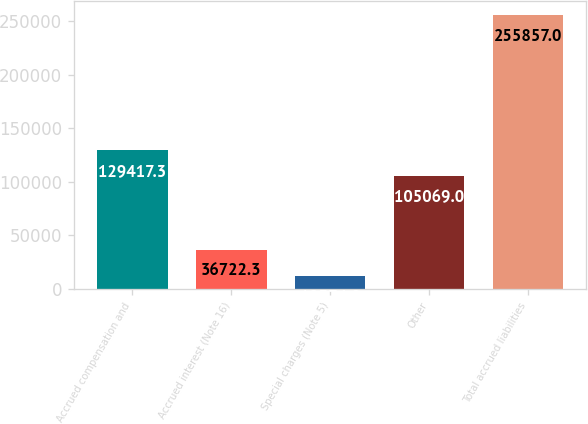Convert chart to OTSL. <chart><loc_0><loc_0><loc_500><loc_500><bar_chart><fcel>Accrued compensation and<fcel>Accrued interest (Note 16)<fcel>Special charges (Note 5)<fcel>Other<fcel>Total accrued liabilities<nl><fcel>129417<fcel>36722.3<fcel>12374<fcel>105069<fcel>255857<nl></chart> 